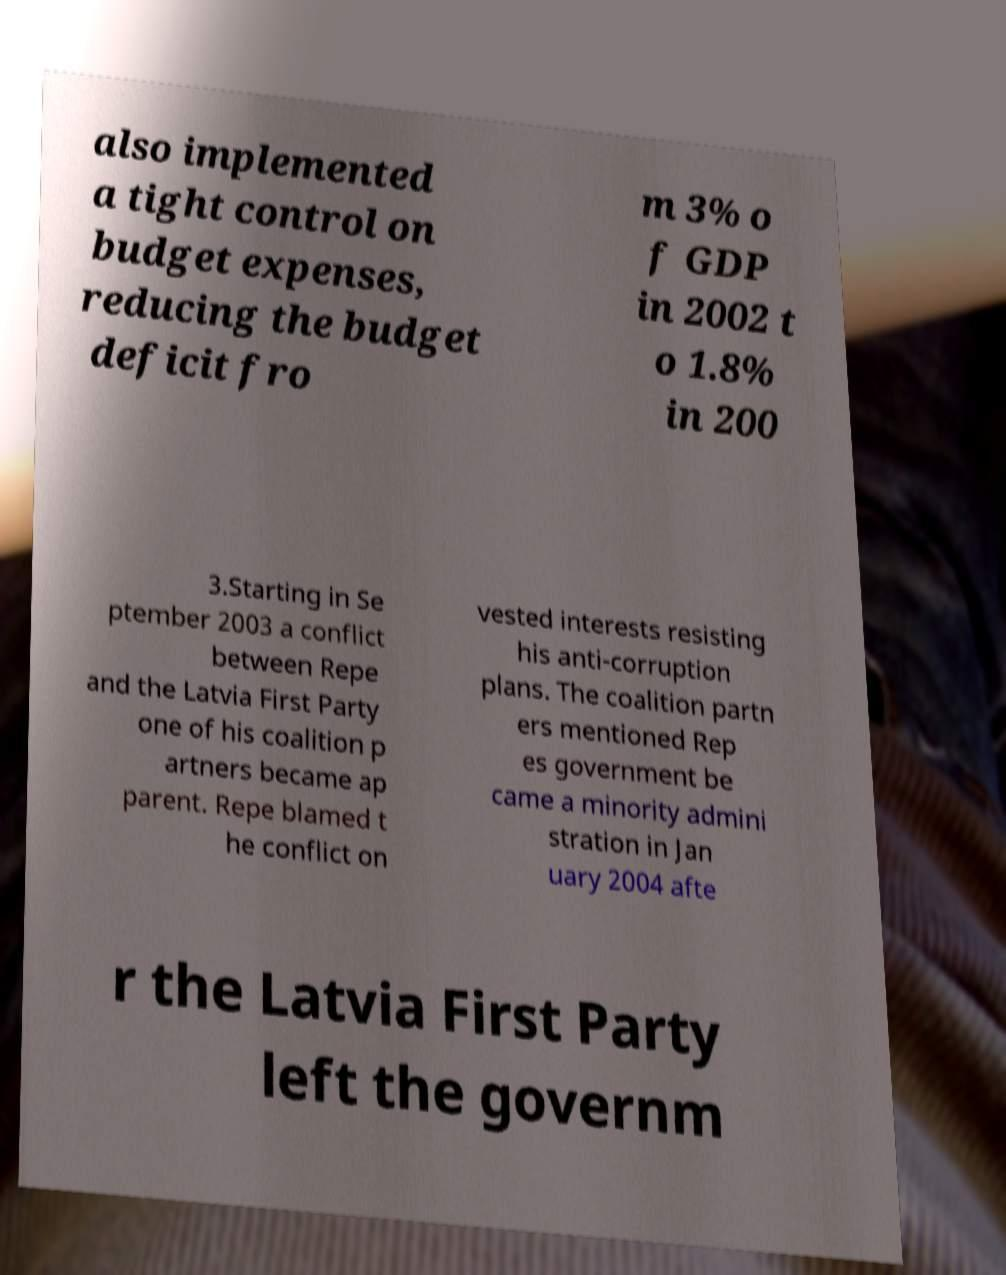I need the written content from this picture converted into text. Can you do that? also implemented a tight control on budget expenses, reducing the budget deficit fro m 3% o f GDP in 2002 t o 1.8% in 200 3.Starting in Se ptember 2003 a conflict between Repe and the Latvia First Party one of his coalition p artners became ap parent. Repe blamed t he conflict on vested interests resisting his anti-corruption plans. The coalition partn ers mentioned Rep es government be came a minority admini stration in Jan uary 2004 afte r the Latvia First Party left the governm 